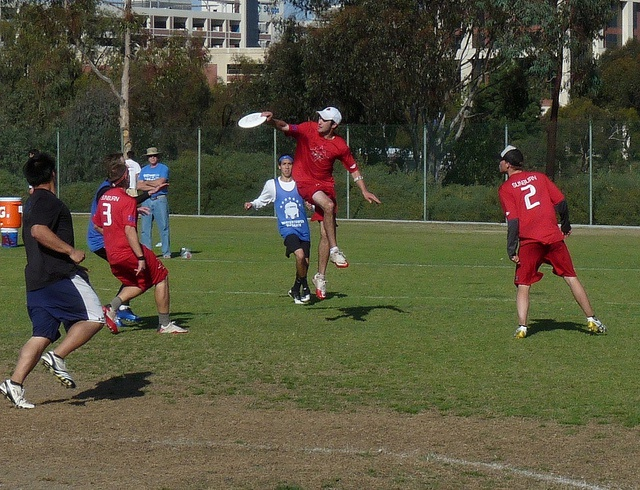Describe the objects in this image and their specific colors. I can see people in gray, black, and navy tones, people in gray, brown, black, maroon, and darkgreen tones, people in gray, brown, maroon, and black tones, people in gray, brown, maroon, and black tones, and people in gray, black, lightgray, and blue tones in this image. 